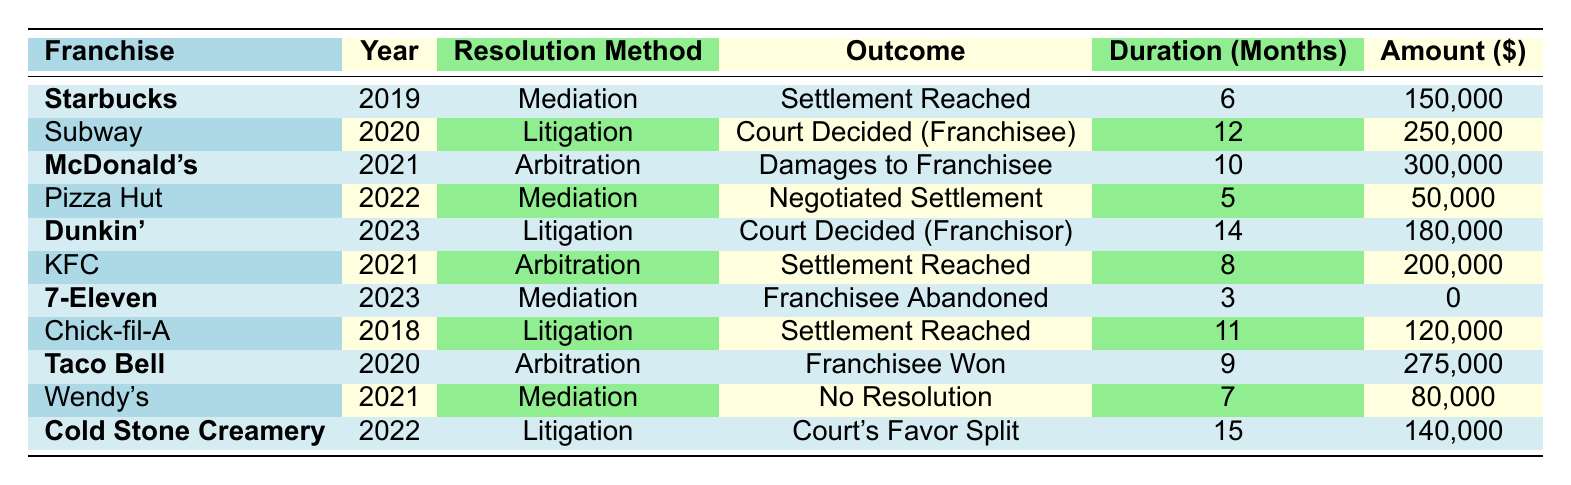What resolution method was used for the Dunkin' case in 2023? The table shows that Dunkin' used "Litigation" as the resolution method in 2023.
Answer: Litigation What was the outcome of the McDonald's dispute in 2021? According to the table, the outcome for McDonald's in 2021 was "Damages Awarded to Franchisee."
Answer: Damages Awarded to Franchisee How many months did it take to resolve the 7-Eleven case in 2023? The table indicates that the duration for resolving the 7-Eleven case was 3 months.
Answer: 3 months What is the total amount involved in disputes for the franchises that reached a settlement in 2019 and 2021? The amounts for settlements in 2019 (Starbucks: $150,000) and 2021 (McDonald's: $300,000) add up to $150,000 + $300,000 = $450,000.
Answer: $450,000 Did any franchisee win their case through arbitration in 2020, according to the table? The table shows that Taco Bell had an outcome of "Franchisee Won Case" through arbitration in 2020, which is a yes.
Answer: Yes Which franchise had the longest duration for dispute resolution, and how long was it? The table lists the dispute for Cold Stone Creamery in 2022 with a duration of 15 months, which is the longest duration.
Answer: Cold Stone Creamery, 15 months What was the outcome of the dispute resolution for Subway in 2020? The table indicates that Subway's dispute resolution resulted in "Court Decided in Favor of Franchisee."
Answer: Court Decided in Favor of Franchisee What is the difference in months between the duration of the litigation for Dunkin' and the mediation for Starbucks? Dunkin' had a duration of 14 months and Starbucks had a duration of 6 months, so the difference is 14 - 6 = 8 months.
Answer: 8 months How many cases involved mediation, and which franchises were they? There are 3 mediation cases in the table: Starbucks (2019), Pizza Hut (2022), and 7-Eleven (2023).
Answer: 3 cases: Starbucks, Pizza Hut, 7-Eleven Was there a case in 2023 where the franchisee abandoned the claim, and which franchise was it? The table shows that 7-Eleven had a case in 2023 where the franchisee abandoned the claim.
Answer: 7-Eleven 